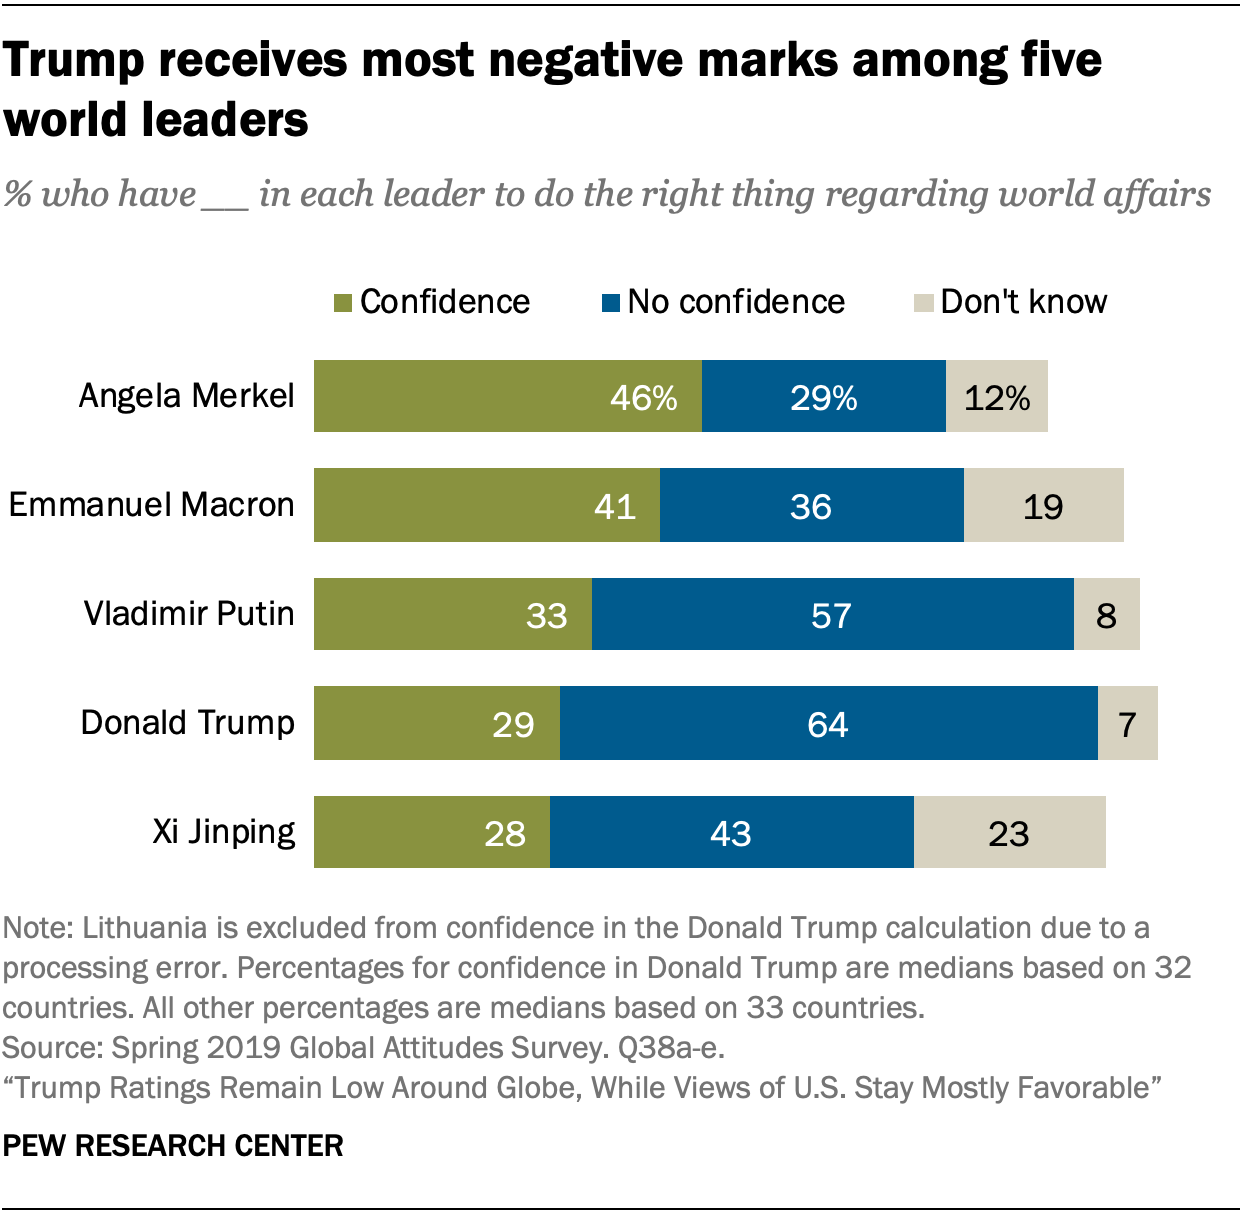Indicate a few pertinent items in this graphic. The No Confidence value of Vladimir Putin is less than that of Donald Trump. A recent survey indicates that 46% of people have confidence in Angela Merkel, the Chancellor of Germany. 